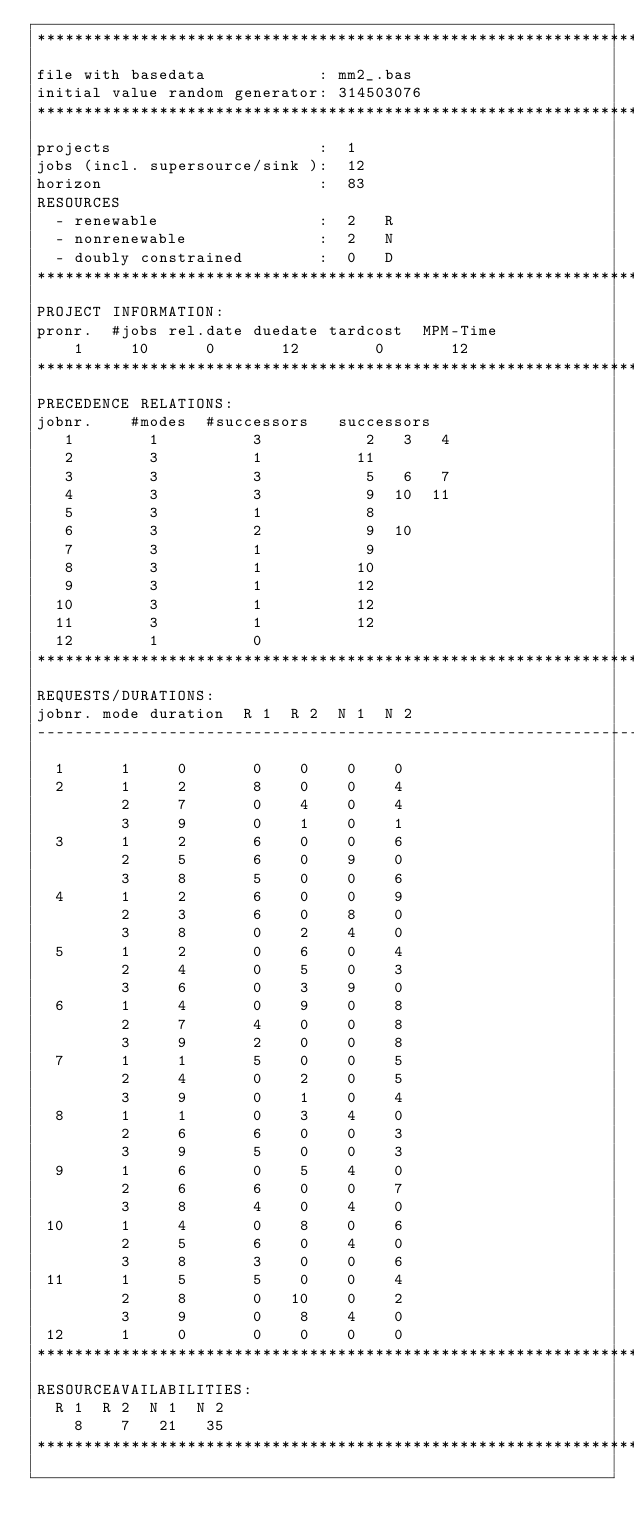<code> <loc_0><loc_0><loc_500><loc_500><_ObjectiveC_>************************************************************************
file with basedata            : mm2_.bas
initial value random generator: 314503076
************************************************************************
projects                      :  1
jobs (incl. supersource/sink ):  12
horizon                       :  83
RESOURCES
  - renewable                 :  2   R
  - nonrenewable              :  2   N
  - doubly constrained        :  0   D
************************************************************************
PROJECT INFORMATION:
pronr.  #jobs rel.date duedate tardcost  MPM-Time
    1     10      0       12        0       12
************************************************************************
PRECEDENCE RELATIONS:
jobnr.    #modes  #successors   successors
   1        1          3           2   3   4
   2        3          1          11
   3        3          3           5   6   7
   4        3          3           9  10  11
   5        3          1           8
   6        3          2           9  10
   7        3          1           9
   8        3          1          10
   9        3          1          12
  10        3          1          12
  11        3          1          12
  12        1          0        
************************************************************************
REQUESTS/DURATIONS:
jobnr. mode duration  R 1  R 2  N 1  N 2
------------------------------------------------------------------------
  1      1     0       0    0    0    0
  2      1     2       8    0    0    4
         2     7       0    4    0    4
         3     9       0    1    0    1
  3      1     2       6    0    0    6
         2     5       6    0    9    0
         3     8       5    0    0    6
  4      1     2       6    0    0    9
         2     3       6    0    8    0
         3     8       0    2    4    0
  5      1     2       0    6    0    4
         2     4       0    5    0    3
         3     6       0    3    9    0
  6      1     4       0    9    0    8
         2     7       4    0    0    8
         3     9       2    0    0    8
  7      1     1       5    0    0    5
         2     4       0    2    0    5
         3     9       0    1    0    4
  8      1     1       0    3    4    0
         2     6       6    0    0    3
         3     9       5    0    0    3
  9      1     6       0    5    4    0
         2     6       6    0    0    7
         3     8       4    0    4    0
 10      1     4       0    8    0    6
         2     5       6    0    4    0
         3     8       3    0    0    6
 11      1     5       5    0    0    4
         2     8       0   10    0    2
         3     9       0    8    4    0
 12      1     0       0    0    0    0
************************************************************************
RESOURCEAVAILABILITIES:
  R 1  R 2  N 1  N 2
    8    7   21   35
************************************************************************
</code> 